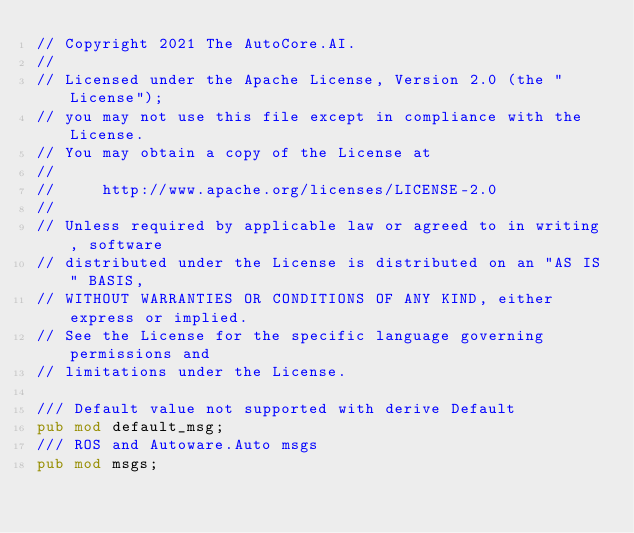Convert code to text. <code><loc_0><loc_0><loc_500><loc_500><_Rust_>// Copyright 2021 The AutoCore.AI.
//
// Licensed under the Apache License, Version 2.0 (the "License");
// you may not use this file except in compliance with the License.
// You may obtain a copy of the License at
//
//     http://www.apache.org/licenses/LICENSE-2.0
//
// Unless required by applicable law or agreed to in writing, software
// distributed under the License is distributed on an "AS IS" BASIS,
// WITHOUT WARRANTIES OR CONDITIONS OF ANY KIND, either express or implied.
// See the License for the specific language governing permissions and
// limitations under the License.

/// Default value not supported with derive Default
pub mod default_msg;
/// ROS and Autoware.Auto msgs
pub mod msgs;
</code> 